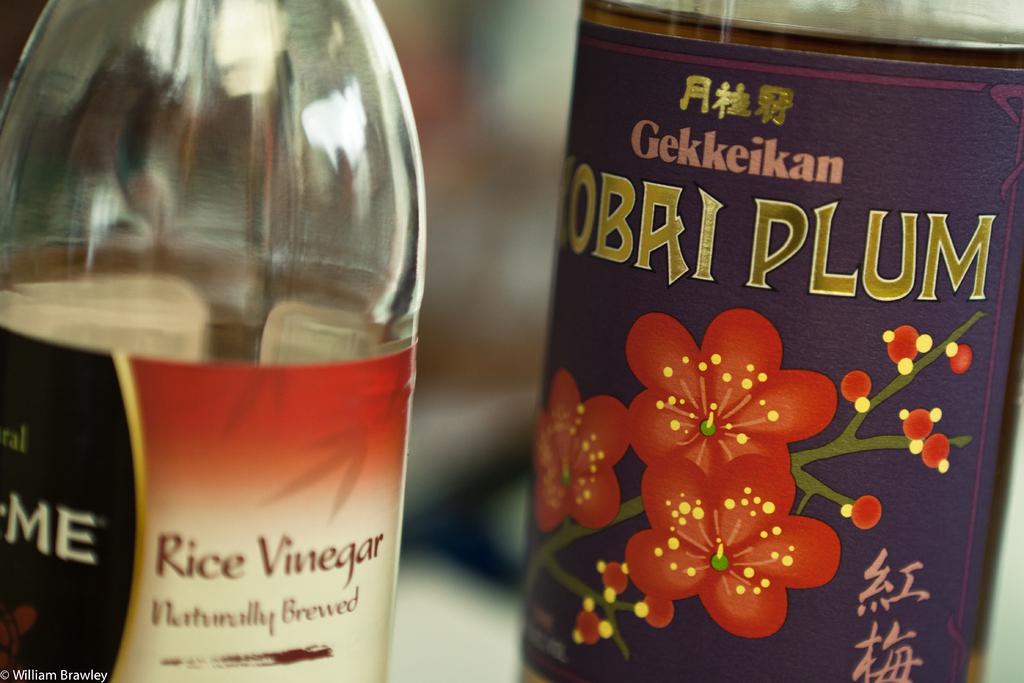What why of vinegar?
Keep it short and to the point. Not a question. What is the fruit word written in gold?
Make the answer very short. Plum. 